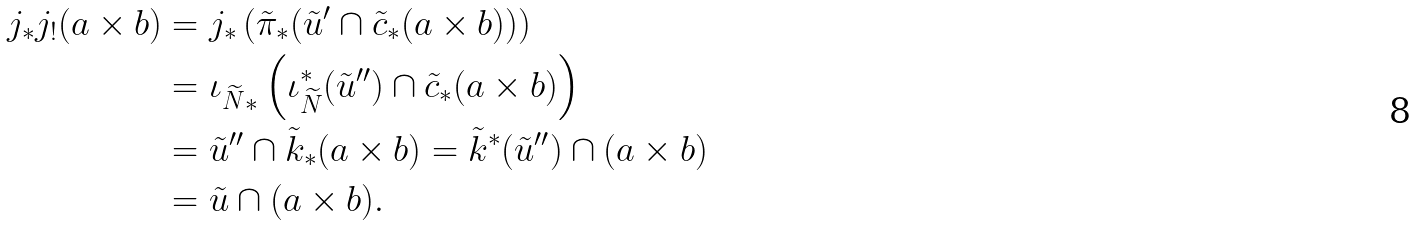Convert formula to latex. <formula><loc_0><loc_0><loc_500><loc_500>j _ { * } j _ { ! } ( a \times b ) & = j _ { * } \left ( \tilde { \pi } _ { * } ( \tilde { u } ^ { \prime } \cap \tilde { c } _ { * } ( a \times b ) ) \right ) \\ & = { \iota _ { \widetilde { N } } } _ { * } \left ( \iota _ { \widetilde { N } } ^ { * } ( \tilde { u } ^ { \prime \prime } ) \cap \tilde { c } _ { * } ( a \times b ) \right ) \\ & = \tilde { u } ^ { \prime \prime } \cap \tilde { k } _ { * } ( a \times b ) = \tilde { k } ^ { * } ( \tilde { u } ^ { \prime \prime } ) \cap ( a \times b ) \\ & = \tilde { u } \cap ( a \times b ) .</formula> 